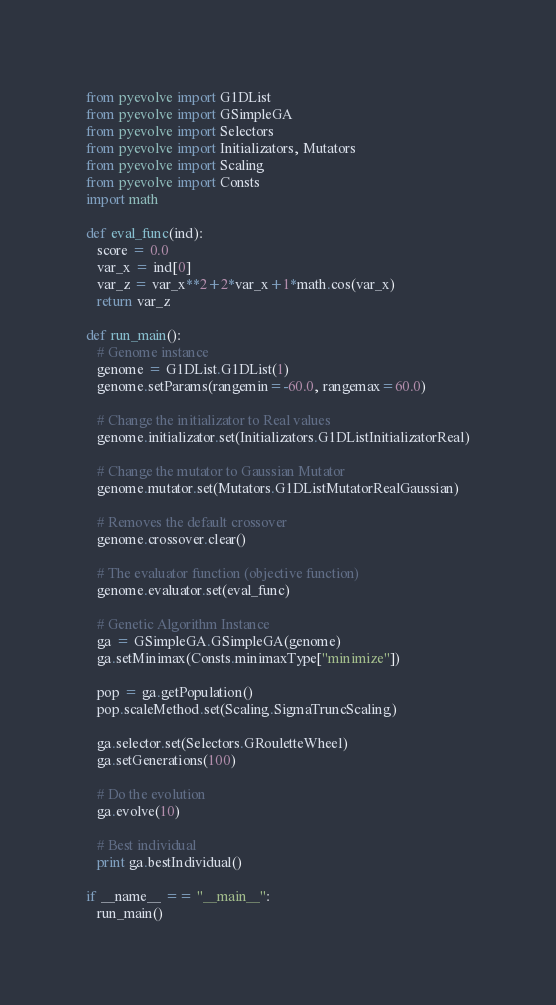<code> <loc_0><loc_0><loc_500><loc_500><_Python_>from pyevolve import G1DList
from pyevolve import GSimpleGA
from pyevolve import Selectors
from pyevolve import Initializators, Mutators
from pyevolve import Scaling
from pyevolve import Consts
import math

def eval_func(ind):
   score = 0.0
   var_x = ind[0]
   var_z = var_x**2+2*var_x+1*math.cos(var_x)
   return var_z

def run_main():
   # Genome instance
   genome = G1DList.G1DList(1)
   genome.setParams(rangemin=-60.0, rangemax=60.0)

   # Change the initializator to Real values
   genome.initializator.set(Initializators.G1DListInitializatorReal)

   # Change the mutator to Gaussian Mutator
   genome.mutator.set(Mutators.G1DListMutatorRealGaussian)

   # Removes the default crossover
   genome.crossover.clear()

   # The evaluator function (objective function)
   genome.evaluator.set(eval_func)

   # Genetic Algorithm Instance
   ga = GSimpleGA.GSimpleGA(genome)
   ga.setMinimax(Consts.minimaxType["minimize"])

   pop = ga.getPopulation()
   pop.scaleMethod.set(Scaling.SigmaTruncScaling)

   ga.selector.set(Selectors.GRouletteWheel)
   ga.setGenerations(100)

   # Do the evolution
   ga.evolve(10)

   # Best individual
   print ga.bestIndividual()

if __name__ == "__main__":
   run_main()
</code> 